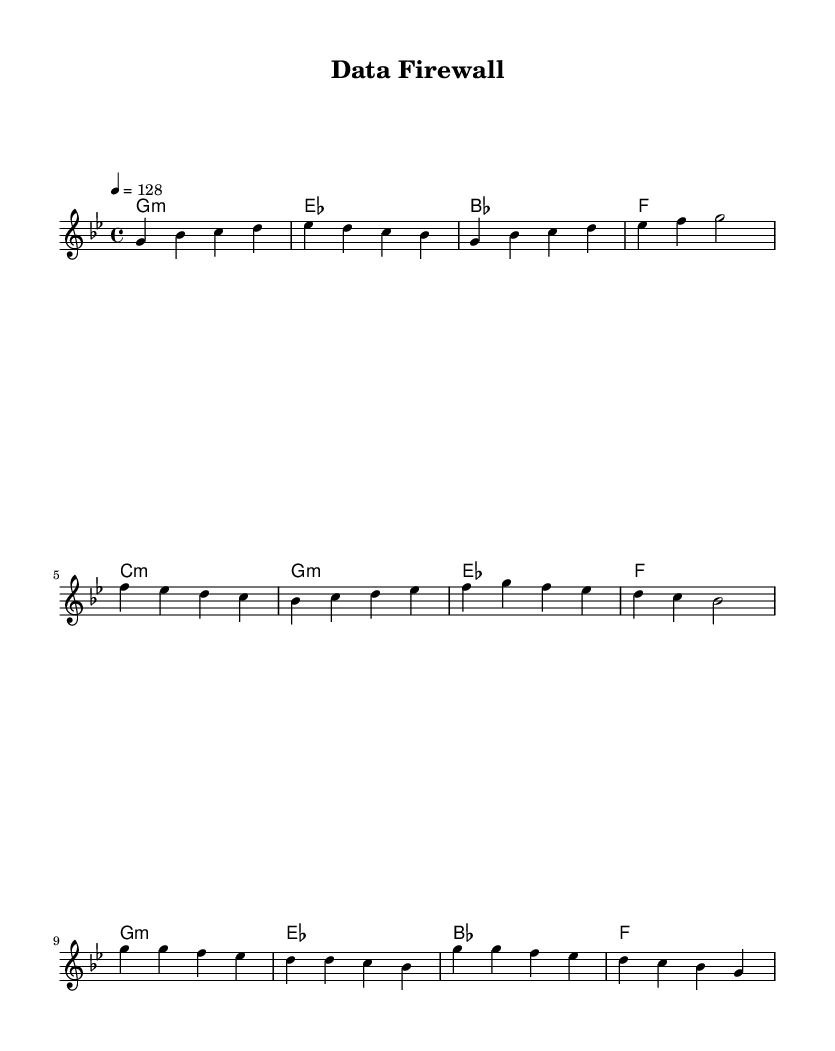What is the key signature of this music? The key signature notated at the beginning indicates G minor, which has two flats (B flat and E flat).
Answer: G minor What is the time signature of this music? The time signature is indicated at the beginning and shows that the piece is in 4/4 time. This means there are four beats in each measure.
Answer: 4/4 What is the tempo of the piece? The tempo marking indicates that the piece should be played at 128 beats per minute, making it a fairly upbeat tempo typical for dance music.
Answer: 128 How many measures are in the verse section? Counting the measures in the melody section that are labeled as the verse reveals there are four measures present.
Answer: 4 What is the primary theme discussed in the lyrics? The lyrics focus on data security and privacy concerns, discussing topics like encrypted walls, anonymity, and securing data, which is relevant to current digital issues.
Answer: Data security What type of musical structure does this song utilize? The structure includes a verse, pre-chorus, and chorus, which is a common framework in K-pop dance music, facilitating engaging and memorable melodies.
Answer: Verse, Pre-Chorus, Chorus What do the lyrics indicate about privacy? The lyrics emphasize the importance of privacy by stating "Privacy's the prize we recognize", highlighting the value placed on keeping personal data secure.
Answer: Importance of privacy 